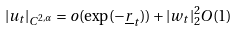Convert formula to latex. <formula><loc_0><loc_0><loc_500><loc_500>| u _ { t } | _ { C ^ { 2 , \alpha } } = o ( \exp ( - \underline { r } _ { t } ) ) + | w _ { t } | _ { 2 } ^ { 2 } O ( 1 )</formula> 